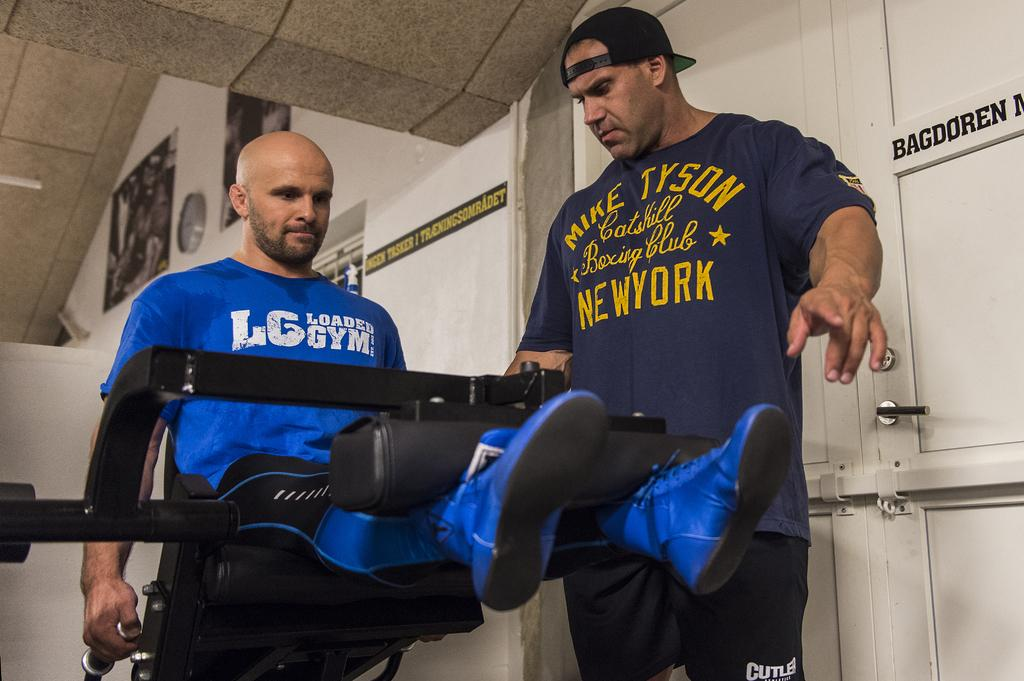<image>
Share a concise interpretation of the image provided. Two men in a gym, one of whom has the name Mike Tyson on his tee shirt. 